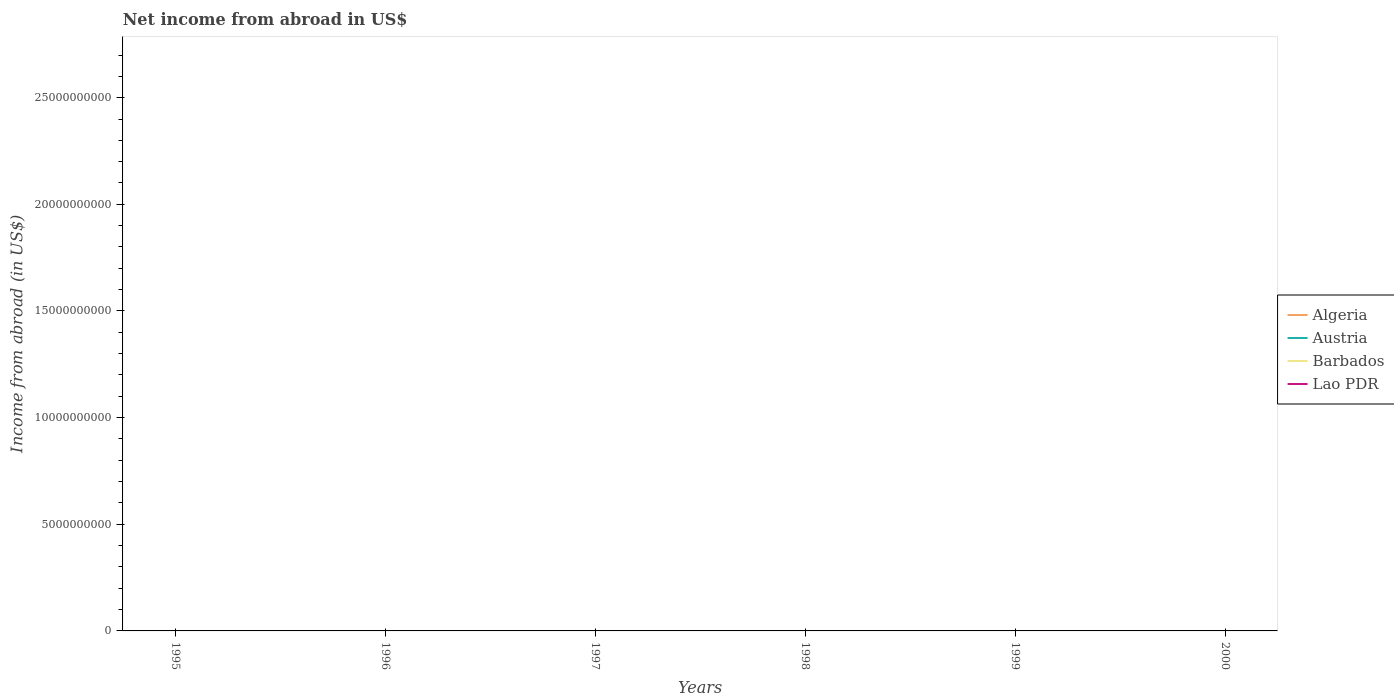What is the difference between the highest and the lowest net income from abroad in Barbados?
Give a very brief answer. 0. How many lines are there?
Your answer should be compact. 0. Are the values on the major ticks of Y-axis written in scientific E-notation?
Keep it short and to the point. No. Does the graph contain any zero values?
Your answer should be compact. Yes. Where does the legend appear in the graph?
Offer a terse response. Center right. What is the title of the graph?
Ensure brevity in your answer.  Net income from abroad in US$. What is the label or title of the Y-axis?
Keep it short and to the point. Income from abroad (in US$). What is the Income from abroad (in US$) of Algeria in 1995?
Provide a succinct answer. 0. What is the Income from abroad (in US$) of Austria in 1995?
Offer a terse response. 0. What is the Income from abroad (in US$) in Algeria in 1996?
Ensure brevity in your answer.  0. What is the Income from abroad (in US$) in Austria in 1996?
Make the answer very short. 0. What is the Income from abroad (in US$) of Algeria in 1997?
Ensure brevity in your answer.  0. What is the Income from abroad (in US$) of Algeria in 1998?
Provide a succinct answer. 0. What is the Income from abroad (in US$) of Algeria in 1999?
Provide a short and direct response. 0. What is the Income from abroad (in US$) in Austria in 1999?
Provide a short and direct response. 0. What is the Income from abroad (in US$) in Algeria in 2000?
Ensure brevity in your answer.  0. What is the Income from abroad (in US$) in Austria in 2000?
Your answer should be compact. 0. What is the Income from abroad (in US$) in Barbados in 2000?
Make the answer very short. 0. What is the total Income from abroad (in US$) of Algeria in the graph?
Your response must be concise. 0. What is the total Income from abroad (in US$) in Austria in the graph?
Your answer should be compact. 0. What is the total Income from abroad (in US$) in Barbados in the graph?
Give a very brief answer. 0. What is the total Income from abroad (in US$) in Lao PDR in the graph?
Your answer should be very brief. 0. What is the average Income from abroad (in US$) in Austria per year?
Offer a terse response. 0. What is the average Income from abroad (in US$) of Barbados per year?
Keep it short and to the point. 0. What is the average Income from abroad (in US$) in Lao PDR per year?
Offer a very short reply. 0. 